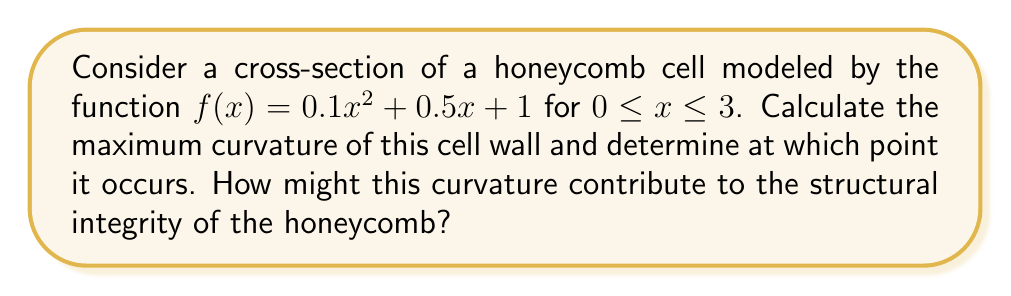Teach me how to tackle this problem. To analyze the curvature of the honeycomb cell, we'll use the formula for curvature:

$$\kappa = \frac{|f''(x)|}{(1 + [f'(x)]^2)^{3/2}}$$

Step 1: Find $f'(x)$ and $f''(x)$
$f'(x) = 0.2x + 0.5$
$f''(x) = 0.2$

Step 2: Substitute into the curvature formula
$$\kappa = \frac{|0.2|}{(1 + [0.2x + 0.5]^2)^{3/2}}$$

Step 3: Simplify
$$\kappa = \frac{0.2}{(1 + 0.04x^2 + 0.2x + 0.25)^{3/2}}$$

Step 4: To find the maximum curvature, we need to find where $\frac{d\kappa}{dx} = 0$. However, since the numerator is constant and the denominator is always increasing as x increases, the maximum curvature will occur at the smallest possible x-value, which is x = 0.

Step 5: Calculate the maximum curvature at x = 0
$$\kappa_{max} = \frac{0.2}{(1 + 0.25)^{3/2}} = \frac{0.2}{1.25^{3/2}} \approx 0.1431$$

The maximum curvature occurs at x = 0, which corresponds to the bottom of the cell wall. This high curvature at the base provides strength and stability to the structure. The gradual decrease in curvature as we move up the cell wall (as x increases) allows for a balance between strength and material efficiency, contributing to the overall structural integrity of the honeycomb.
Answer: Maximum curvature ≈ 0.1431, occurring at x = 0 